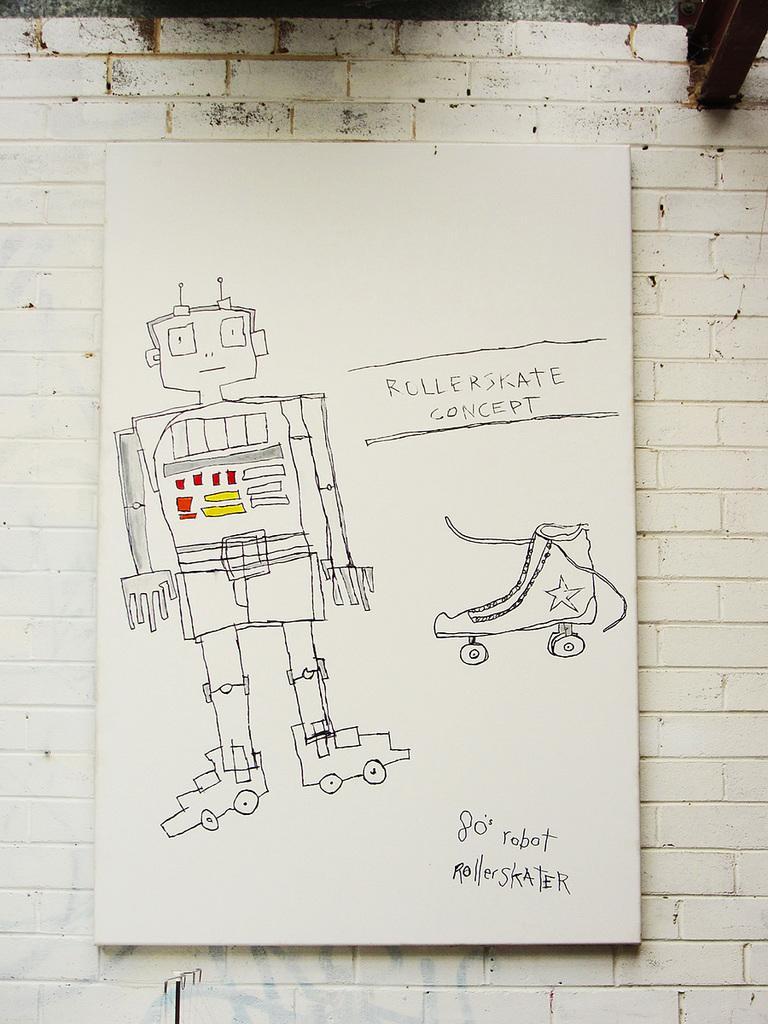Describe this image in one or two sentences. In the image there is a sketch art of robot and skating shoe along with some text on the wall. 